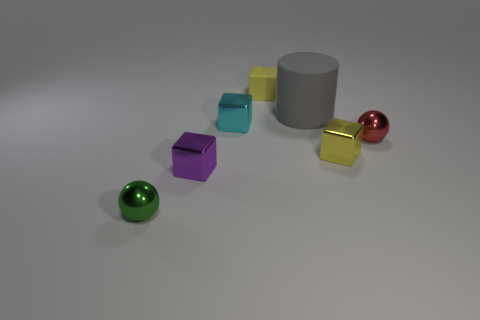What is the ball on the right side of the shiny ball that is left of the small cyan thing made of?
Provide a succinct answer. Metal. There is a object that is the same color as the tiny rubber block; what is its material?
Offer a terse response. Metal. The large object has what color?
Offer a very short reply. Gray. There is a sphere that is left of the purple metallic object; is there a small red ball that is in front of it?
Provide a short and direct response. No. What material is the tiny red ball?
Provide a short and direct response. Metal. Is the material of the small yellow block in front of the gray cylinder the same as the thing behind the gray rubber object?
Your answer should be compact. No. Are there any other things that have the same color as the big rubber cylinder?
Provide a succinct answer. No. There is another matte thing that is the same shape as the cyan object; what color is it?
Provide a short and direct response. Yellow. What size is the metallic cube that is both to the left of the gray cylinder and in front of the tiny cyan metal thing?
Give a very brief answer. Small. Do the tiny yellow thing that is behind the cyan object and the yellow metal object that is behind the tiny green object have the same shape?
Keep it short and to the point. Yes. 